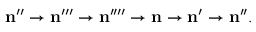Convert formula to latex. <formula><loc_0><loc_0><loc_500><loc_500>n ^ { \prime \prime } \rightarrow n ^ { \prime \prime \prime } \rightarrow n ^ { \prime \prime \prime \prime } \rightarrow n \rightarrow n ^ { \prime } \rightarrow n ^ { \prime \prime } .</formula> 